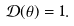Convert formula to latex. <formula><loc_0><loc_0><loc_500><loc_500>\mathcal { D } ( \theta ) = 1 .</formula> 